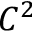<formula> <loc_0><loc_0><loc_500><loc_500>C ^ { 2 }</formula> 